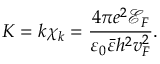Convert formula to latex. <formula><loc_0><loc_0><loc_500><loc_500>K = k \chi _ { k } = \frac { 4 \pi e ^ { 2 } \ m a t h s c r { E } _ { F } } { \varepsilon _ { 0 } \bar { \varepsilon } h ^ { 2 } v _ { F } ^ { 2 } } .</formula> 